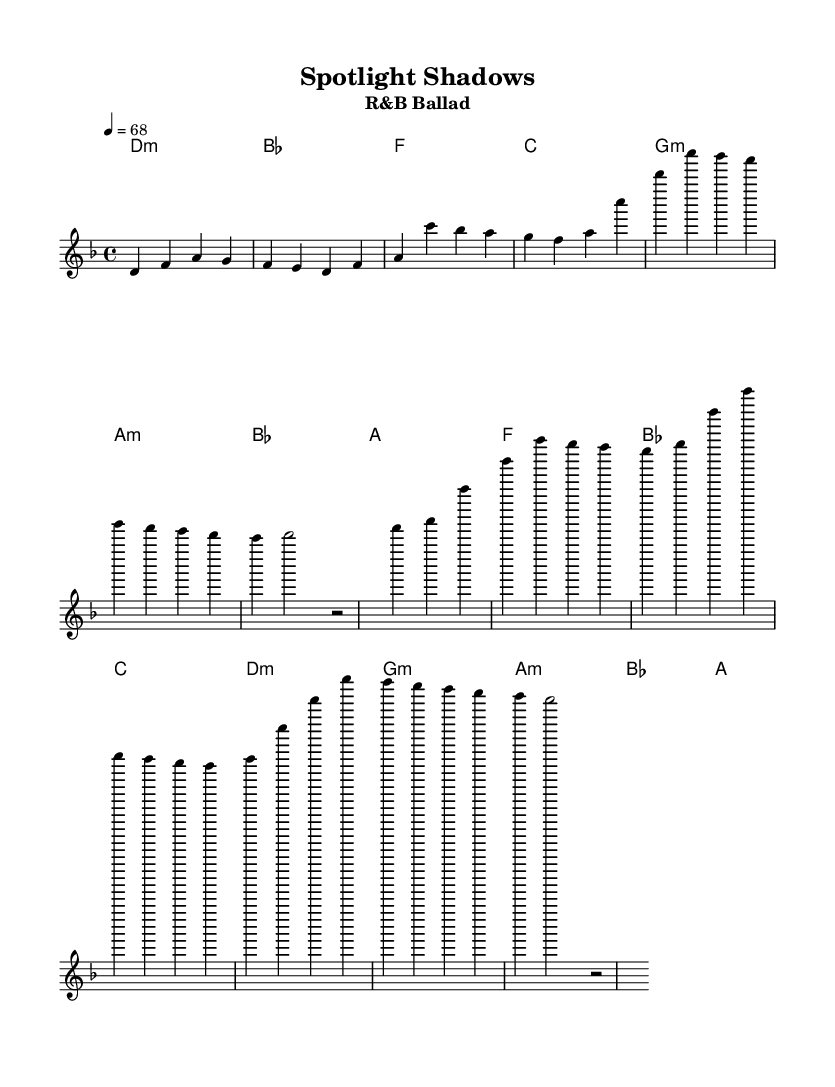What is the key signature of this music? The key signature is indicated by the presence of one flat in the key signature area at the beginning of the staff. In this case, it indicates D minor.
Answer: D minor What is the time signature of this music? The time signature is represented at the beginning of the staff, showing that there are four beats in each measure, identified as 4/4.
Answer: 4/4 What is the tempo marking for this piece? The tempo is specified in the tempo indication, stating "4 = 68," which suggests a relatively slow pace.
Answer: 68 How many measures are there in the verse section? By counting the measures in the melody part marked for the verse, there are a total of four measures visually represented.
Answer: Four What is the chord for the first measure? The chord indicated in the harmony part for the first measure is a D minor chord, as designated in the chord name section.
Answer: D minor How many lines of lyrics are in the chorus? The lyrics for the chorus are laid out over four lines, as indicated by their separate placement and spacing when aligned with the music notes.
Answer: Four Which emotional theme does this song focus on? The lyrics and overall theme reflect the emotional toll of managing high-profile clients, emphasizing the contrast between public persona and private struggles.
Answer: Emotional toll 